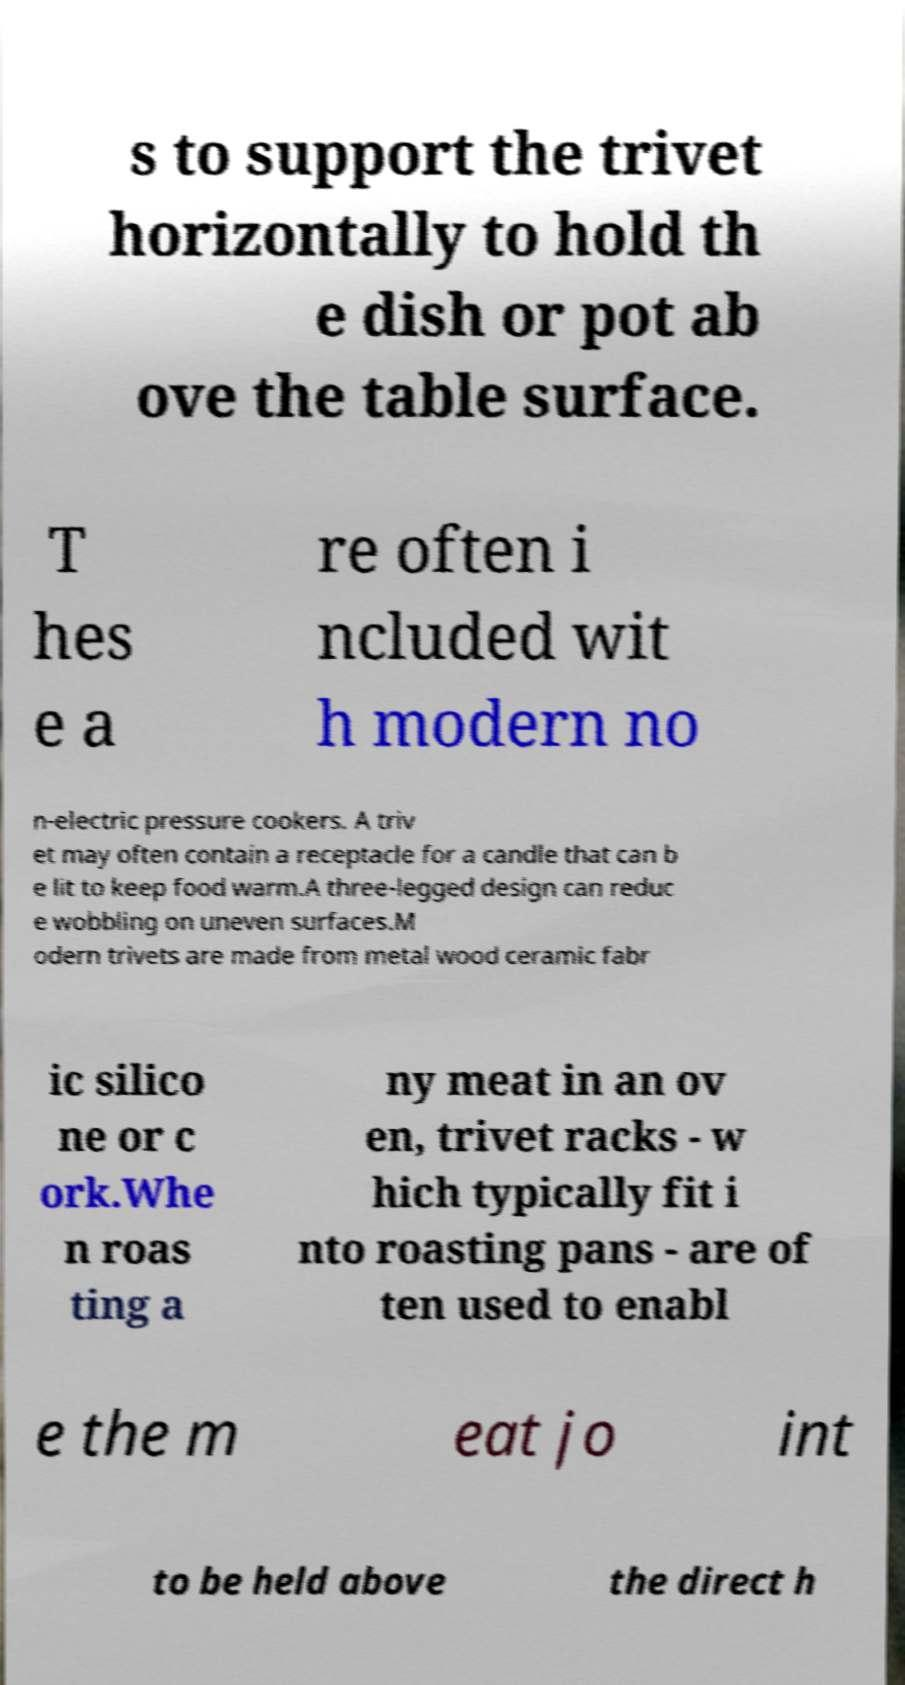Could you extract and type out the text from this image? s to support the trivet horizontally to hold th e dish or pot ab ove the table surface. T hes e a re often i ncluded wit h modern no n-electric pressure cookers. A triv et may often contain a receptacle for a candle that can b e lit to keep food warm.A three-legged design can reduc e wobbling on uneven surfaces.M odern trivets are made from metal wood ceramic fabr ic silico ne or c ork.Whe n roas ting a ny meat in an ov en, trivet racks - w hich typically fit i nto roasting pans - are of ten used to enabl e the m eat jo int to be held above the direct h 